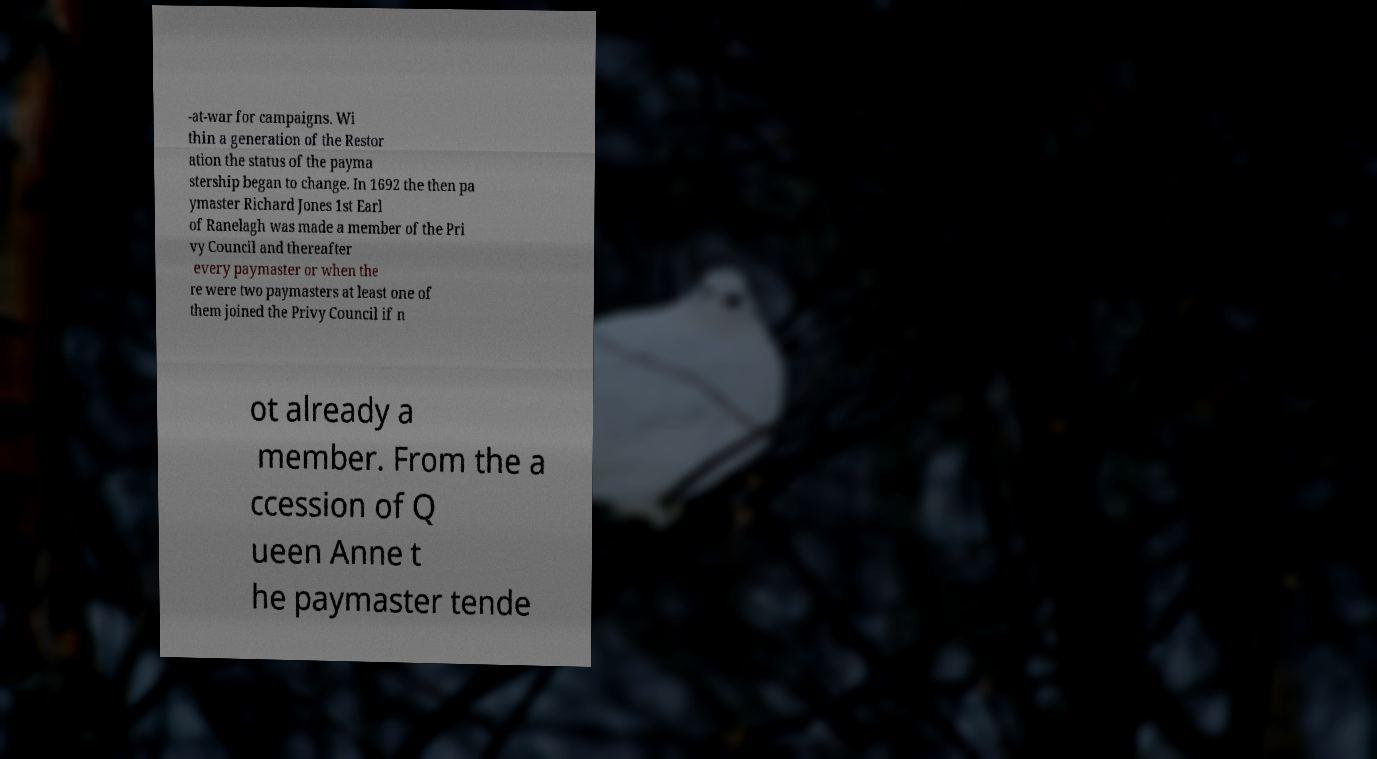Could you assist in decoding the text presented in this image and type it out clearly? -at-war for campaigns. Wi thin a generation of the Restor ation the status of the payma stership began to change. In 1692 the then pa ymaster Richard Jones 1st Earl of Ranelagh was made a member of the Pri vy Council and thereafter every paymaster or when the re were two paymasters at least one of them joined the Privy Council if n ot already a member. From the a ccession of Q ueen Anne t he paymaster tende 